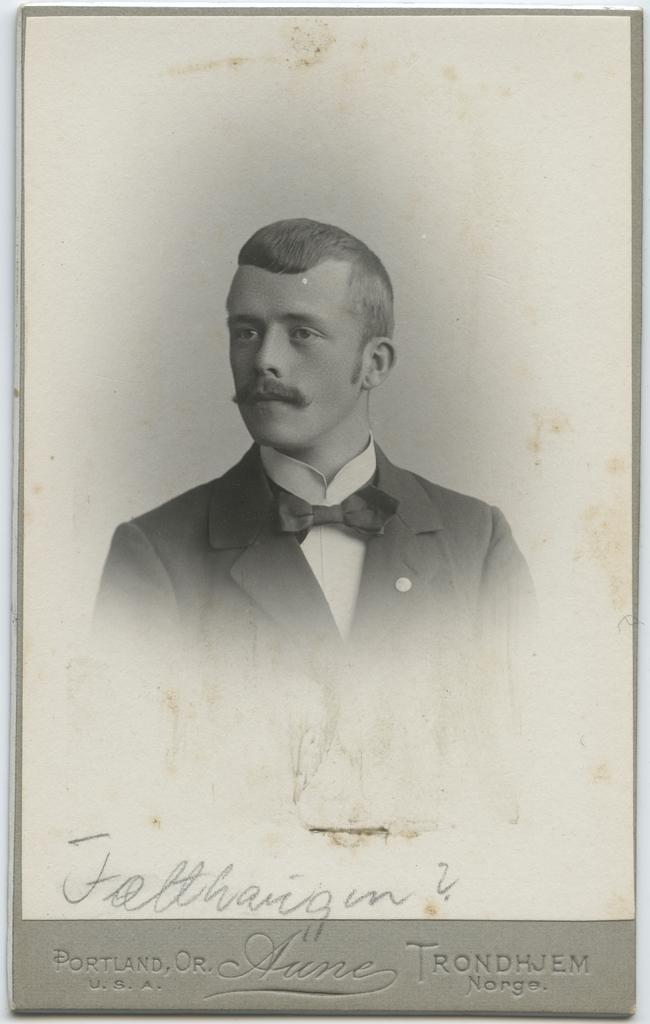What is the main subject of the image? There is a photograph in the image. What level of experience does the photographer have in oil painting, as depicted in the image? There is no information about the photographer's experience in oil painting or any reference to oil painting in the image. 